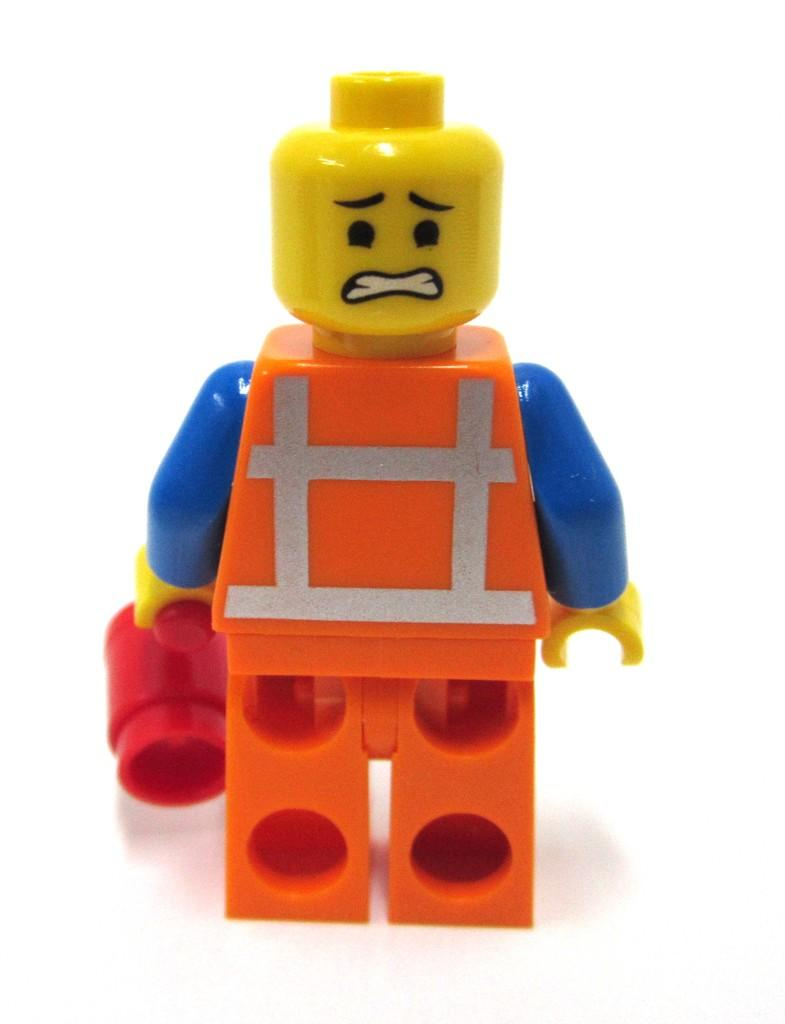What is the main subject of the image? There is a toy in the center of the image. What type of gold control can be seen in the image? There is no gold control present in the image; it features a toy in the center. How does the toy's behavior change throughout the image? The toy's behavior cannot be determined from the image, as it is a still image and not a video. 